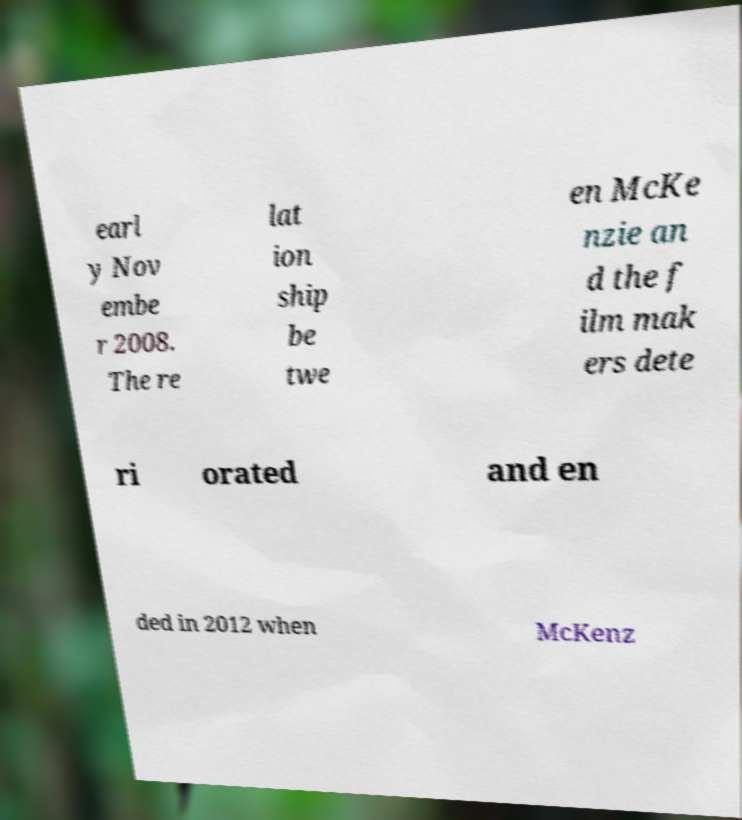Could you extract and type out the text from this image? earl y Nov embe r 2008. The re lat ion ship be twe en McKe nzie an d the f ilm mak ers dete ri orated and en ded in 2012 when McKenz 